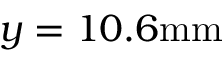<formula> <loc_0><loc_0><loc_500><loc_500>y = 1 0 . 6 m m</formula> 